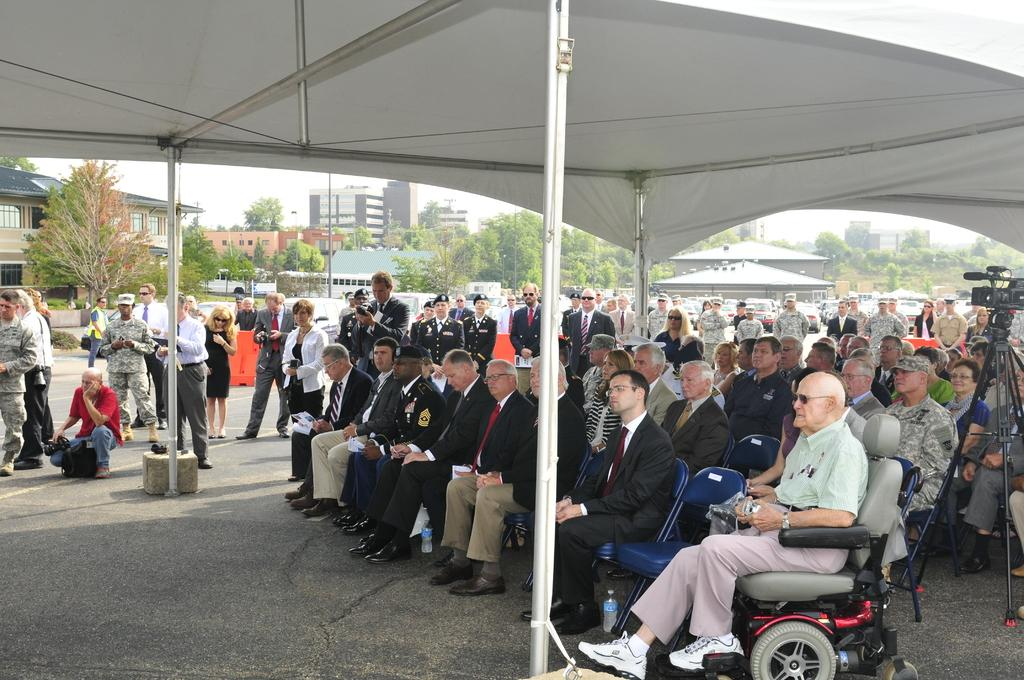What are the people in the image doing? There is a group of people sitting on chairs, and there are people standing in the image. What equipment is present for capturing images? There is a camera with a tripod in the image. What type of shelter is visible in the image? There is a tent in the image. What can be seen in the background of the image? There are trees, buildings, and the sky visible in the background. What type of mint plant can be seen growing near the tent in the image? There is no mint plant visible in the image; it only features a tent, people, and background elements. 